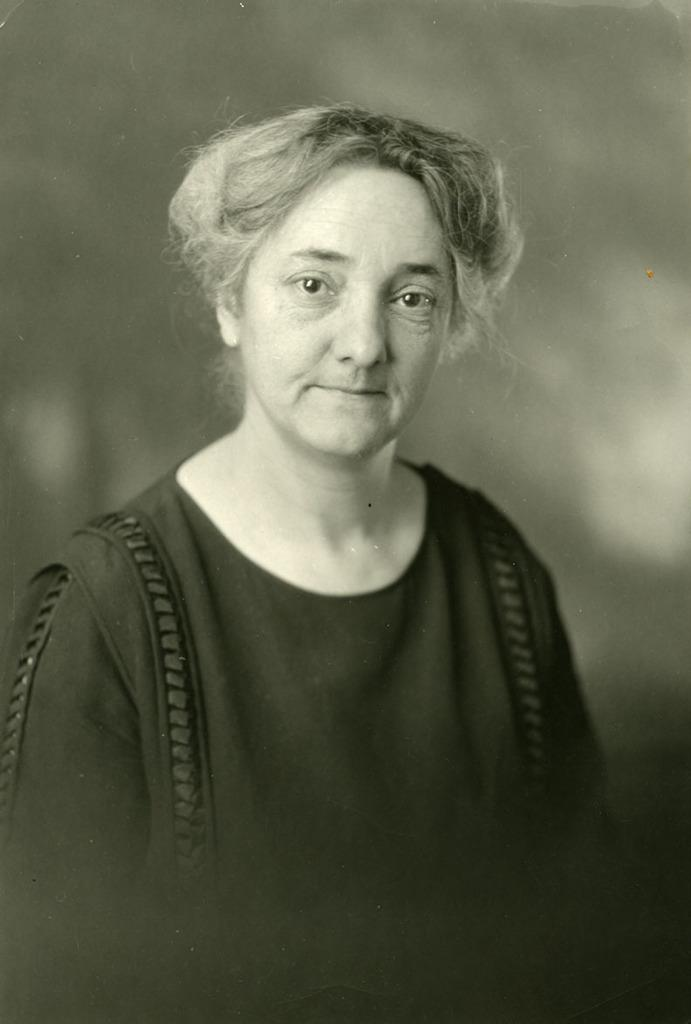Who is the main subject in the image? There is a woman in the center of the image. What type of watch is the woman wearing in the image? There is no watch visible in the image; the woman is the only subject mentioned in the provided fact. 